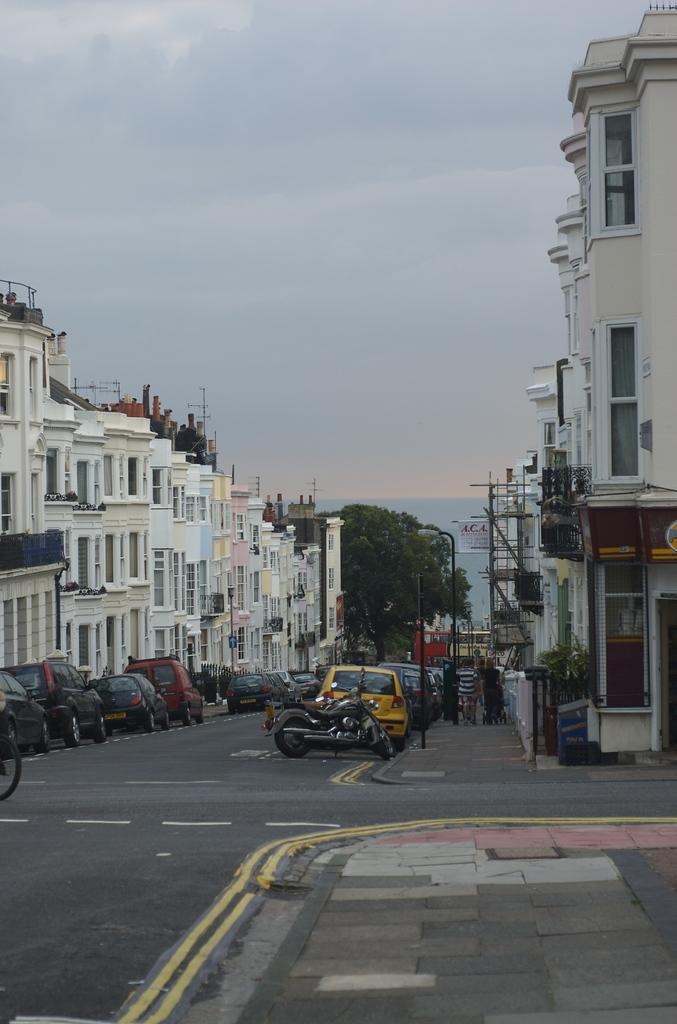Can you describe this image briefly? This is a street view. I can see the buildings on the right and left sides of the image. I can see trees and poles in the center of the image. Vehicles on the road, and a footpath with a pavement and at the top of the image I can see the sky. 